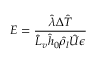Convert formula to latex. <formula><loc_0><loc_0><loc_500><loc_500>E = \frac { \hat { \lambda } \Delta \hat { T } } { \hat { L } _ { v } \hat { h } _ { 0 } \hat { \rho } _ { l } \hat { U } \epsilon }</formula> 